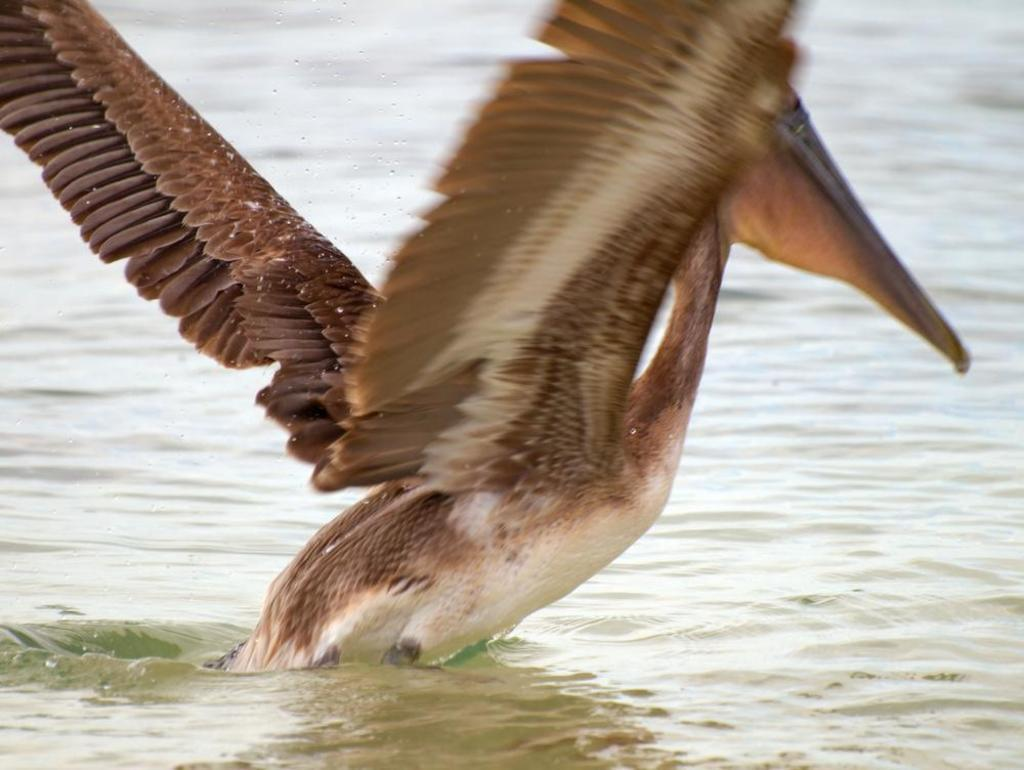What is the main subject of the picture? The main subject of the picture is a crane. What can be seen at the bottom of the picture? There is water at the bottom of the picture. What type of bucket is being used by the crane in the image? There is no bucket present in the image; the crane is the main subject. What is the condition of the sand in the image? There is no sand present in the image, only water at the bottom. 